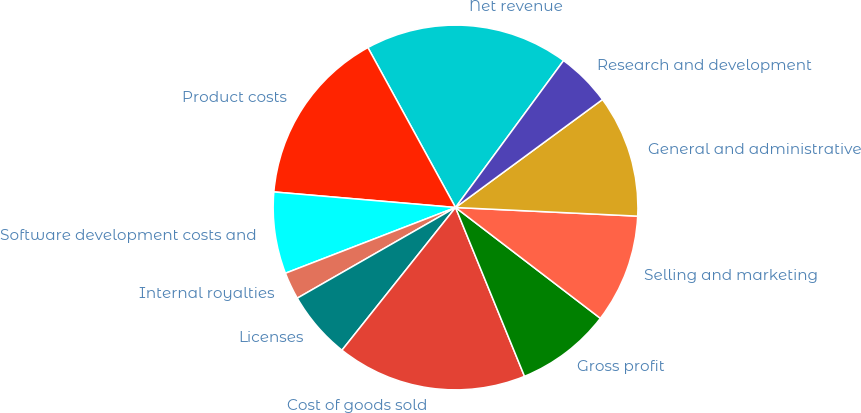<chart> <loc_0><loc_0><loc_500><loc_500><pie_chart><fcel>Net revenue<fcel>Product costs<fcel>Software development costs and<fcel>Internal royalties<fcel>Licenses<fcel>Cost of goods sold<fcel>Gross profit<fcel>Selling and marketing<fcel>General and administrative<fcel>Research and development<nl><fcel>18.07%<fcel>15.66%<fcel>7.23%<fcel>2.41%<fcel>6.02%<fcel>16.87%<fcel>8.43%<fcel>9.64%<fcel>10.84%<fcel>4.82%<nl></chart> 